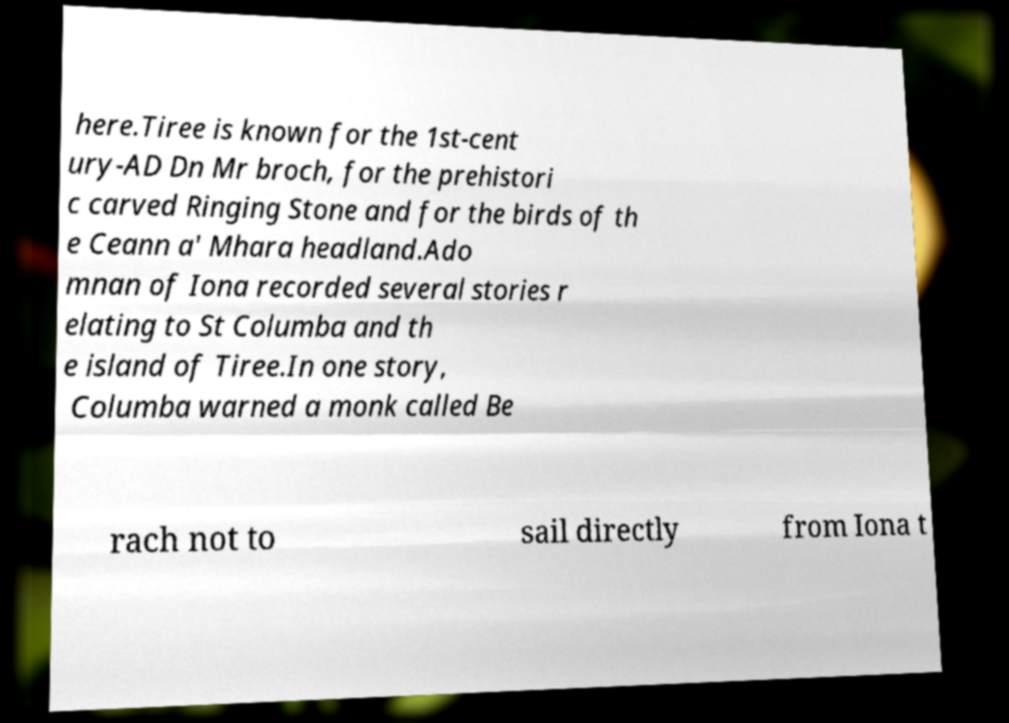What messages or text are displayed in this image? I need them in a readable, typed format. here.Tiree is known for the 1st-cent ury-AD Dn Mr broch, for the prehistori c carved Ringing Stone and for the birds of th e Ceann a' Mhara headland.Ado mnan of Iona recorded several stories r elating to St Columba and th e island of Tiree.In one story, Columba warned a monk called Be rach not to sail directly from Iona t 